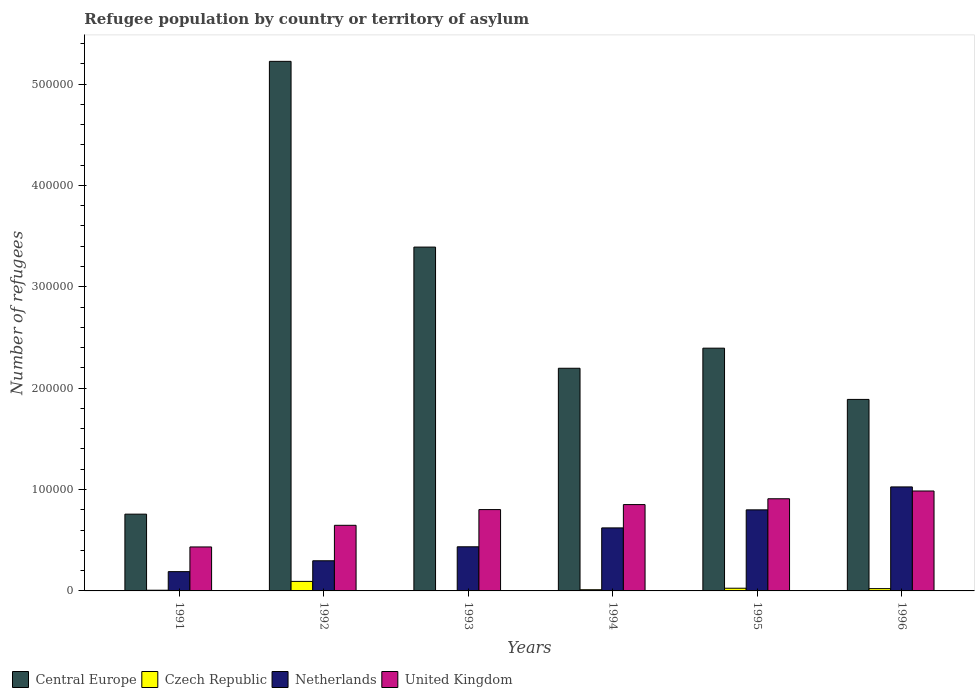Are the number of bars on each tick of the X-axis equal?
Give a very brief answer. Yes. How many bars are there on the 3rd tick from the right?
Your answer should be compact. 4. What is the label of the 5th group of bars from the left?
Provide a short and direct response. 1995. What is the number of refugees in Netherlands in 1992?
Your answer should be very brief. 2.97e+04. Across all years, what is the maximum number of refugees in Czech Republic?
Offer a terse response. 9399. Across all years, what is the minimum number of refugees in Czech Republic?
Give a very brief answer. 188. In which year was the number of refugees in Netherlands maximum?
Offer a very short reply. 1996. What is the total number of refugees in Czech Republic in the graph?
Offer a terse response. 1.64e+04. What is the difference between the number of refugees in United Kingdom in 1991 and that in 1993?
Ensure brevity in your answer.  -3.69e+04. What is the difference between the number of refugees in United Kingdom in 1991 and the number of refugees in Netherlands in 1995?
Your answer should be compact. -3.66e+04. What is the average number of refugees in Central Europe per year?
Your response must be concise. 2.64e+05. In the year 1993, what is the difference between the number of refugees in Central Europe and number of refugees in United Kingdom?
Provide a succinct answer. 2.59e+05. What is the ratio of the number of refugees in Czech Republic in 1991 to that in 1993?
Provide a short and direct response. 3.68. What is the difference between the highest and the second highest number of refugees in United Kingdom?
Offer a terse response. 7668. What is the difference between the highest and the lowest number of refugees in Czech Republic?
Offer a terse response. 9211. Is it the case that in every year, the sum of the number of refugees in Czech Republic and number of refugees in Netherlands is greater than the sum of number of refugees in United Kingdom and number of refugees in Central Europe?
Make the answer very short. No. What does the 3rd bar from the left in 1994 represents?
Ensure brevity in your answer.  Netherlands. What does the 1st bar from the right in 1995 represents?
Your answer should be compact. United Kingdom. How many bars are there?
Make the answer very short. 24. How many years are there in the graph?
Offer a terse response. 6. What is the difference between two consecutive major ticks on the Y-axis?
Your response must be concise. 1.00e+05. Does the graph contain any zero values?
Provide a short and direct response. No. What is the title of the graph?
Your response must be concise. Refugee population by country or territory of asylum. Does "Armenia" appear as one of the legend labels in the graph?
Give a very brief answer. No. What is the label or title of the Y-axis?
Offer a very short reply. Number of refugees. What is the Number of refugees of Central Europe in 1991?
Your response must be concise. 7.57e+04. What is the Number of refugees in Czech Republic in 1991?
Offer a very short reply. 691. What is the Number of refugees of Netherlands in 1991?
Your answer should be very brief. 1.90e+04. What is the Number of refugees in United Kingdom in 1991?
Offer a very short reply. 4.34e+04. What is the Number of refugees in Central Europe in 1992?
Give a very brief answer. 5.22e+05. What is the Number of refugees of Czech Republic in 1992?
Your answer should be compact. 9399. What is the Number of refugees of Netherlands in 1992?
Give a very brief answer. 2.97e+04. What is the Number of refugees of United Kingdom in 1992?
Your answer should be very brief. 6.47e+04. What is the Number of refugees in Central Europe in 1993?
Provide a short and direct response. 3.39e+05. What is the Number of refugees of Czech Republic in 1993?
Provide a succinct answer. 188. What is the Number of refugees of Netherlands in 1993?
Your answer should be very brief. 4.35e+04. What is the Number of refugees of United Kingdom in 1993?
Ensure brevity in your answer.  8.02e+04. What is the Number of refugees of Central Europe in 1994?
Provide a succinct answer. 2.20e+05. What is the Number of refugees of Czech Republic in 1994?
Your response must be concise. 1186. What is the Number of refugees in Netherlands in 1994?
Make the answer very short. 6.22e+04. What is the Number of refugees of United Kingdom in 1994?
Provide a short and direct response. 8.52e+04. What is the Number of refugees of Central Europe in 1995?
Your answer should be very brief. 2.39e+05. What is the Number of refugees of Czech Republic in 1995?
Offer a terse response. 2655. What is the Number of refugees in Netherlands in 1995?
Keep it short and to the point. 8.00e+04. What is the Number of refugees in United Kingdom in 1995?
Provide a short and direct response. 9.09e+04. What is the Number of refugees in Central Europe in 1996?
Offer a terse response. 1.89e+05. What is the Number of refugees in Czech Republic in 1996?
Give a very brief answer. 2266. What is the Number of refugees in Netherlands in 1996?
Provide a succinct answer. 1.03e+05. What is the Number of refugees of United Kingdom in 1996?
Provide a short and direct response. 9.86e+04. Across all years, what is the maximum Number of refugees in Central Europe?
Make the answer very short. 5.22e+05. Across all years, what is the maximum Number of refugees of Czech Republic?
Provide a short and direct response. 9399. Across all years, what is the maximum Number of refugees in Netherlands?
Your answer should be very brief. 1.03e+05. Across all years, what is the maximum Number of refugees in United Kingdom?
Offer a terse response. 9.86e+04. Across all years, what is the minimum Number of refugees of Central Europe?
Your response must be concise. 7.57e+04. Across all years, what is the minimum Number of refugees of Czech Republic?
Your answer should be very brief. 188. Across all years, what is the minimum Number of refugees in Netherlands?
Your answer should be very brief. 1.90e+04. Across all years, what is the minimum Number of refugees of United Kingdom?
Offer a very short reply. 4.34e+04. What is the total Number of refugees of Central Europe in the graph?
Offer a terse response. 1.59e+06. What is the total Number of refugees of Czech Republic in the graph?
Your answer should be compact. 1.64e+04. What is the total Number of refugees of Netherlands in the graph?
Make the answer very short. 3.37e+05. What is the total Number of refugees of United Kingdom in the graph?
Offer a very short reply. 4.63e+05. What is the difference between the Number of refugees in Central Europe in 1991 and that in 1992?
Offer a very short reply. -4.47e+05. What is the difference between the Number of refugees in Czech Republic in 1991 and that in 1992?
Your response must be concise. -8708. What is the difference between the Number of refugees of Netherlands in 1991 and that in 1992?
Your answer should be compact. -1.07e+04. What is the difference between the Number of refugees of United Kingdom in 1991 and that in 1992?
Ensure brevity in your answer.  -2.14e+04. What is the difference between the Number of refugees in Central Europe in 1991 and that in 1993?
Your answer should be very brief. -2.63e+05. What is the difference between the Number of refugees of Czech Republic in 1991 and that in 1993?
Provide a short and direct response. 503. What is the difference between the Number of refugees in Netherlands in 1991 and that in 1993?
Make the answer very short. -2.45e+04. What is the difference between the Number of refugees in United Kingdom in 1991 and that in 1993?
Ensure brevity in your answer.  -3.69e+04. What is the difference between the Number of refugees of Central Europe in 1991 and that in 1994?
Ensure brevity in your answer.  -1.44e+05. What is the difference between the Number of refugees in Czech Republic in 1991 and that in 1994?
Keep it short and to the point. -495. What is the difference between the Number of refugees in Netherlands in 1991 and that in 1994?
Ensure brevity in your answer.  -4.31e+04. What is the difference between the Number of refugees in United Kingdom in 1991 and that in 1994?
Offer a very short reply. -4.18e+04. What is the difference between the Number of refugees in Central Europe in 1991 and that in 1995?
Offer a very short reply. -1.64e+05. What is the difference between the Number of refugees of Czech Republic in 1991 and that in 1995?
Your answer should be compact. -1964. What is the difference between the Number of refugees of Netherlands in 1991 and that in 1995?
Keep it short and to the point. -6.09e+04. What is the difference between the Number of refugees in United Kingdom in 1991 and that in 1995?
Offer a terse response. -4.75e+04. What is the difference between the Number of refugees in Central Europe in 1991 and that in 1996?
Provide a short and direct response. -1.13e+05. What is the difference between the Number of refugees of Czech Republic in 1991 and that in 1996?
Provide a short and direct response. -1575. What is the difference between the Number of refugees of Netherlands in 1991 and that in 1996?
Make the answer very short. -8.36e+04. What is the difference between the Number of refugees of United Kingdom in 1991 and that in 1996?
Provide a short and direct response. -5.52e+04. What is the difference between the Number of refugees of Central Europe in 1992 and that in 1993?
Offer a terse response. 1.83e+05. What is the difference between the Number of refugees in Czech Republic in 1992 and that in 1993?
Ensure brevity in your answer.  9211. What is the difference between the Number of refugees in Netherlands in 1992 and that in 1993?
Offer a terse response. -1.38e+04. What is the difference between the Number of refugees in United Kingdom in 1992 and that in 1993?
Provide a succinct answer. -1.55e+04. What is the difference between the Number of refugees in Central Europe in 1992 and that in 1994?
Your answer should be compact. 3.03e+05. What is the difference between the Number of refugees in Czech Republic in 1992 and that in 1994?
Your response must be concise. 8213. What is the difference between the Number of refugees of Netherlands in 1992 and that in 1994?
Keep it short and to the point. -3.24e+04. What is the difference between the Number of refugees of United Kingdom in 1992 and that in 1994?
Offer a very short reply. -2.04e+04. What is the difference between the Number of refugees of Central Europe in 1992 and that in 1995?
Ensure brevity in your answer.  2.83e+05. What is the difference between the Number of refugees in Czech Republic in 1992 and that in 1995?
Keep it short and to the point. 6744. What is the difference between the Number of refugees in Netherlands in 1992 and that in 1995?
Your answer should be compact. -5.02e+04. What is the difference between the Number of refugees of United Kingdom in 1992 and that in 1995?
Provide a succinct answer. -2.62e+04. What is the difference between the Number of refugees in Central Europe in 1992 and that in 1996?
Your response must be concise. 3.33e+05. What is the difference between the Number of refugees of Czech Republic in 1992 and that in 1996?
Provide a succinct answer. 7133. What is the difference between the Number of refugees in Netherlands in 1992 and that in 1996?
Your answer should be very brief. -7.28e+04. What is the difference between the Number of refugees of United Kingdom in 1992 and that in 1996?
Keep it short and to the point. -3.39e+04. What is the difference between the Number of refugees of Central Europe in 1993 and that in 1994?
Your answer should be very brief. 1.20e+05. What is the difference between the Number of refugees of Czech Republic in 1993 and that in 1994?
Your answer should be very brief. -998. What is the difference between the Number of refugees in Netherlands in 1993 and that in 1994?
Your response must be concise. -1.86e+04. What is the difference between the Number of refugees of United Kingdom in 1993 and that in 1994?
Provide a short and direct response. -4930. What is the difference between the Number of refugees of Central Europe in 1993 and that in 1995?
Keep it short and to the point. 9.97e+04. What is the difference between the Number of refugees in Czech Republic in 1993 and that in 1995?
Make the answer very short. -2467. What is the difference between the Number of refugees of Netherlands in 1993 and that in 1995?
Ensure brevity in your answer.  -3.64e+04. What is the difference between the Number of refugees in United Kingdom in 1993 and that in 1995?
Provide a succinct answer. -1.07e+04. What is the difference between the Number of refugees of Central Europe in 1993 and that in 1996?
Your answer should be compact. 1.50e+05. What is the difference between the Number of refugees in Czech Republic in 1993 and that in 1996?
Provide a short and direct response. -2078. What is the difference between the Number of refugees of Netherlands in 1993 and that in 1996?
Make the answer very short. -5.90e+04. What is the difference between the Number of refugees of United Kingdom in 1993 and that in 1996?
Ensure brevity in your answer.  -1.83e+04. What is the difference between the Number of refugees of Central Europe in 1994 and that in 1995?
Give a very brief answer. -1.98e+04. What is the difference between the Number of refugees of Czech Republic in 1994 and that in 1995?
Provide a short and direct response. -1469. What is the difference between the Number of refugees in Netherlands in 1994 and that in 1995?
Provide a succinct answer. -1.78e+04. What is the difference between the Number of refugees of United Kingdom in 1994 and that in 1995?
Provide a succinct answer. -5749. What is the difference between the Number of refugees in Central Europe in 1994 and that in 1996?
Give a very brief answer. 3.07e+04. What is the difference between the Number of refugees of Czech Republic in 1994 and that in 1996?
Your answer should be compact. -1080. What is the difference between the Number of refugees in Netherlands in 1994 and that in 1996?
Your answer should be very brief. -4.04e+04. What is the difference between the Number of refugees of United Kingdom in 1994 and that in 1996?
Give a very brief answer. -1.34e+04. What is the difference between the Number of refugees of Central Europe in 1995 and that in 1996?
Keep it short and to the point. 5.06e+04. What is the difference between the Number of refugees of Czech Republic in 1995 and that in 1996?
Keep it short and to the point. 389. What is the difference between the Number of refugees of Netherlands in 1995 and that in 1996?
Offer a terse response. -2.26e+04. What is the difference between the Number of refugees of United Kingdom in 1995 and that in 1996?
Your answer should be compact. -7668. What is the difference between the Number of refugees in Central Europe in 1991 and the Number of refugees in Czech Republic in 1992?
Make the answer very short. 6.63e+04. What is the difference between the Number of refugees of Central Europe in 1991 and the Number of refugees of Netherlands in 1992?
Your answer should be very brief. 4.60e+04. What is the difference between the Number of refugees of Central Europe in 1991 and the Number of refugees of United Kingdom in 1992?
Make the answer very short. 1.10e+04. What is the difference between the Number of refugees in Czech Republic in 1991 and the Number of refugees in Netherlands in 1992?
Your answer should be compact. -2.90e+04. What is the difference between the Number of refugees in Czech Republic in 1991 and the Number of refugees in United Kingdom in 1992?
Make the answer very short. -6.40e+04. What is the difference between the Number of refugees in Netherlands in 1991 and the Number of refugees in United Kingdom in 1992?
Offer a very short reply. -4.57e+04. What is the difference between the Number of refugees of Central Europe in 1991 and the Number of refugees of Czech Republic in 1993?
Offer a terse response. 7.55e+04. What is the difference between the Number of refugees in Central Europe in 1991 and the Number of refugees in Netherlands in 1993?
Offer a very short reply. 3.22e+04. What is the difference between the Number of refugees in Central Europe in 1991 and the Number of refugees in United Kingdom in 1993?
Your response must be concise. -4500. What is the difference between the Number of refugees of Czech Republic in 1991 and the Number of refugees of Netherlands in 1993?
Your response must be concise. -4.28e+04. What is the difference between the Number of refugees of Czech Republic in 1991 and the Number of refugees of United Kingdom in 1993?
Give a very brief answer. -7.95e+04. What is the difference between the Number of refugees of Netherlands in 1991 and the Number of refugees of United Kingdom in 1993?
Offer a very short reply. -6.12e+04. What is the difference between the Number of refugees of Central Europe in 1991 and the Number of refugees of Czech Republic in 1994?
Your answer should be very brief. 7.45e+04. What is the difference between the Number of refugees of Central Europe in 1991 and the Number of refugees of Netherlands in 1994?
Make the answer very short. 1.36e+04. What is the difference between the Number of refugees of Central Europe in 1991 and the Number of refugees of United Kingdom in 1994?
Offer a terse response. -9430. What is the difference between the Number of refugees in Czech Republic in 1991 and the Number of refugees in Netherlands in 1994?
Offer a very short reply. -6.15e+04. What is the difference between the Number of refugees of Czech Republic in 1991 and the Number of refugees of United Kingdom in 1994?
Offer a terse response. -8.45e+04. What is the difference between the Number of refugees of Netherlands in 1991 and the Number of refugees of United Kingdom in 1994?
Your response must be concise. -6.61e+04. What is the difference between the Number of refugees of Central Europe in 1991 and the Number of refugees of Czech Republic in 1995?
Offer a terse response. 7.31e+04. What is the difference between the Number of refugees of Central Europe in 1991 and the Number of refugees of Netherlands in 1995?
Offer a very short reply. -4230. What is the difference between the Number of refugees in Central Europe in 1991 and the Number of refugees in United Kingdom in 1995?
Your answer should be very brief. -1.52e+04. What is the difference between the Number of refugees in Czech Republic in 1991 and the Number of refugees in Netherlands in 1995?
Offer a terse response. -7.93e+04. What is the difference between the Number of refugees in Czech Republic in 1991 and the Number of refugees in United Kingdom in 1995?
Make the answer very short. -9.02e+04. What is the difference between the Number of refugees in Netherlands in 1991 and the Number of refugees in United Kingdom in 1995?
Keep it short and to the point. -7.19e+04. What is the difference between the Number of refugees of Central Europe in 1991 and the Number of refugees of Czech Republic in 1996?
Keep it short and to the point. 7.35e+04. What is the difference between the Number of refugees of Central Europe in 1991 and the Number of refugees of Netherlands in 1996?
Offer a very short reply. -2.69e+04. What is the difference between the Number of refugees of Central Europe in 1991 and the Number of refugees of United Kingdom in 1996?
Provide a succinct answer. -2.28e+04. What is the difference between the Number of refugees of Czech Republic in 1991 and the Number of refugees of Netherlands in 1996?
Your response must be concise. -1.02e+05. What is the difference between the Number of refugees of Czech Republic in 1991 and the Number of refugees of United Kingdom in 1996?
Give a very brief answer. -9.79e+04. What is the difference between the Number of refugees in Netherlands in 1991 and the Number of refugees in United Kingdom in 1996?
Your response must be concise. -7.96e+04. What is the difference between the Number of refugees in Central Europe in 1992 and the Number of refugees in Czech Republic in 1993?
Your answer should be very brief. 5.22e+05. What is the difference between the Number of refugees in Central Europe in 1992 and the Number of refugees in Netherlands in 1993?
Your answer should be compact. 4.79e+05. What is the difference between the Number of refugees in Central Europe in 1992 and the Number of refugees in United Kingdom in 1993?
Offer a terse response. 4.42e+05. What is the difference between the Number of refugees of Czech Republic in 1992 and the Number of refugees of Netherlands in 1993?
Your response must be concise. -3.41e+04. What is the difference between the Number of refugees in Czech Republic in 1992 and the Number of refugees in United Kingdom in 1993?
Keep it short and to the point. -7.08e+04. What is the difference between the Number of refugees of Netherlands in 1992 and the Number of refugees of United Kingdom in 1993?
Your answer should be compact. -5.05e+04. What is the difference between the Number of refugees of Central Europe in 1992 and the Number of refugees of Czech Republic in 1994?
Keep it short and to the point. 5.21e+05. What is the difference between the Number of refugees of Central Europe in 1992 and the Number of refugees of Netherlands in 1994?
Keep it short and to the point. 4.60e+05. What is the difference between the Number of refugees in Central Europe in 1992 and the Number of refugees in United Kingdom in 1994?
Offer a terse response. 4.37e+05. What is the difference between the Number of refugees in Czech Republic in 1992 and the Number of refugees in Netherlands in 1994?
Keep it short and to the point. -5.28e+04. What is the difference between the Number of refugees of Czech Republic in 1992 and the Number of refugees of United Kingdom in 1994?
Your answer should be compact. -7.58e+04. What is the difference between the Number of refugees in Netherlands in 1992 and the Number of refugees in United Kingdom in 1994?
Your response must be concise. -5.54e+04. What is the difference between the Number of refugees in Central Europe in 1992 and the Number of refugees in Czech Republic in 1995?
Offer a terse response. 5.20e+05. What is the difference between the Number of refugees in Central Europe in 1992 and the Number of refugees in Netherlands in 1995?
Provide a succinct answer. 4.42e+05. What is the difference between the Number of refugees in Central Europe in 1992 and the Number of refugees in United Kingdom in 1995?
Offer a very short reply. 4.31e+05. What is the difference between the Number of refugees in Czech Republic in 1992 and the Number of refugees in Netherlands in 1995?
Your answer should be very brief. -7.06e+04. What is the difference between the Number of refugees of Czech Republic in 1992 and the Number of refugees of United Kingdom in 1995?
Keep it short and to the point. -8.15e+04. What is the difference between the Number of refugees in Netherlands in 1992 and the Number of refugees in United Kingdom in 1995?
Provide a succinct answer. -6.12e+04. What is the difference between the Number of refugees of Central Europe in 1992 and the Number of refugees of Czech Republic in 1996?
Your answer should be compact. 5.20e+05. What is the difference between the Number of refugees in Central Europe in 1992 and the Number of refugees in Netherlands in 1996?
Ensure brevity in your answer.  4.20e+05. What is the difference between the Number of refugees in Central Europe in 1992 and the Number of refugees in United Kingdom in 1996?
Ensure brevity in your answer.  4.24e+05. What is the difference between the Number of refugees of Czech Republic in 1992 and the Number of refugees of Netherlands in 1996?
Offer a terse response. -9.32e+04. What is the difference between the Number of refugees of Czech Republic in 1992 and the Number of refugees of United Kingdom in 1996?
Your answer should be very brief. -8.92e+04. What is the difference between the Number of refugees in Netherlands in 1992 and the Number of refugees in United Kingdom in 1996?
Offer a terse response. -6.88e+04. What is the difference between the Number of refugees of Central Europe in 1993 and the Number of refugees of Czech Republic in 1994?
Your response must be concise. 3.38e+05. What is the difference between the Number of refugees of Central Europe in 1993 and the Number of refugees of Netherlands in 1994?
Your response must be concise. 2.77e+05. What is the difference between the Number of refugees of Central Europe in 1993 and the Number of refugees of United Kingdom in 1994?
Your answer should be very brief. 2.54e+05. What is the difference between the Number of refugees of Czech Republic in 1993 and the Number of refugees of Netherlands in 1994?
Your response must be concise. -6.20e+04. What is the difference between the Number of refugees of Czech Republic in 1993 and the Number of refugees of United Kingdom in 1994?
Your response must be concise. -8.50e+04. What is the difference between the Number of refugees in Netherlands in 1993 and the Number of refugees in United Kingdom in 1994?
Your response must be concise. -4.16e+04. What is the difference between the Number of refugees of Central Europe in 1993 and the Number of refugees of Czech Republic in 1995?
Keep it short and to the point. 3.37e+05. What is the difference between the Number of refugees in Central Europe in 1993 and the Number of refugees in Netherlands in 1995?
Your response must be concise. 2.59e+05. What is the difference between the Number of refugees of Central Europe in 1993 and the Number of refugees of United Kingdom in 1995?
Provide a succinct answer. 2.48e+05. What is the difference between the Number of refugees of Czech Republic in 1993 and the Number of refugees of Netherlands in 1995?
Provide a succinct answer. -7.98e+04. What is the difference between the Number of refugees of Czech Republic in 1993 and the Number of refugees of United Kingdom in 1995?
Provide a succinct answer. -9.07e+04. What is the difference between the Number of refugees in Netherlands in 1993 and the Number of refugees in United Kingdom in 1995?
Make the answer very short. -4.74e+04. What is the difference between the Number of refugees in Central Europe in 1993 and the Number of refugees in Czech Republic in 1996?
Your answer should be compact. 3.37e+05. What is the difference between the Number of refugees in Central Europe in 1993 and the Number of refugees in Netherlands in 1996?
Provide a succinct answer. 2.37e+05. What is the difference between the Number of refugees of Central Europe in 1993 and the Number of refugees of United Kingdom in 1996?
Offer a terse response. 2.41e+05. What is the difference between the Number of refugees in Czech Republic in 1993 and the Number of refugees in Netherlands in 1996?
Offer a very short reply. -1.02e+05. What is the difference between the Number of refugees of Czech Republic in 1993 and the Number of refugees of United Kingdom in 1996?
Offer a terse response. -9.84e+04. What is the difference between the Number of refugees in Netherlands in 1993 and the Number of refugees in United Kingdom in 1996?
Your response must be concise. -5.50e+04. What is the difference between the Number of refugees of Central Europe in 1994 and the Number of refugees of Czech Republic in 1995?
Offer a very short reply. 2.17e+05. What is the difference between the Number of refugees of Central Europe in 1994 and the Number of refugees of Netherlands in 1995?
Your answer should be compact. 1.40e+05. What is the difference between the Number of refugees of Central Europe in 1994 and the Number of refugees of United Kingdom in 1995?
Offer a very short reply. 1.29e+05. What is the difference between the Number of refugees in Czech Republic in 1994 and the Number of refugees in Netherlands in 1995?
Ensure brevity in your answer.  -7.88e+04. What is the difference between the Number of refugees of Czech Republic in 1994 and the Number of refugees of United Kingdom in 1995?
Make the answer very short. -8.97e+04. What is the difference between the Number of refugees in Netherlands in 1994 and the Number of refugees in United Kingdom in 1995?
Give a very brief answer. -2.87e+04. What is the difference between the Number of refugees of Central Europe in 1994 and the Number of refugees of Czech Republic in 1996?
Ensure brevity in your answer.  2.17e+05. What is the difference between the Number of refugees in Central Europe in 1994 and the Number of refugees in Netherlands in 1996?
Ensure brevity in your answer.  1.17e+05. What is the difference between the Number of refugees of Central Europe in 1994 and the Number of refugees of United Kingdom in 1996?
Keep it short and to the point. 1.21e+05. What is the difference between the Number of refugees in Czech Republic in 1994 and the Number of refugees in Netherlands in 1996?
Ensure brevity in your answer.  -1.01e+05. What is the difference between the Number of refugees in Czech Republic in 1994 and the Number of refugees in United Kingdom in 1996?
Your response must be concise. -9.74e+04. What is the difference between the Number of refugees in Netherlands in 1994 and the Number of refugees in United Kingdom in 1996?
Give a very brief answer. -3.64e+04. What is the difference between the Number of refugees of Central Europe in 1995 and the Number of refugees of Czech Republic in 1996?
Offer a terse response. 2.37e+05. What is the difference between the Number of refugees of Central Europe in 1995 and the Number of refugees of Netherlands in 1996?
Your answer should be compact. 1.37e+05. What is the difference between the Number of refugees of Central Europe in 1995 and the Number of refugees of United Kingdom in 1996?
Provide a succinct answer. 1.41e+05. What is the difference between the Number of refugees of Czech Republic in 1995 and the Number of refugees of Netherlands in 1996?
Offer a terse response. -9.99e+04. What is the difference between the Number of refugees of Czech Republic in 1995 and the Number of refugees of United Kingdom in 1996?
Give a very brief answer. -9.59e+04. What is the difference between the Number of refugees in Netherlands in 1995 and the Number of refugees in United Kingdom in 1996?
Ensure brevity in your answer.  -1.86e+04. What is the average Number of refugees in Central Europe per year?
Provide a succinct answer. 2.64e+05. What is the average Number of refugees in Czech Republic per year?
Give a very brief answer. 2730.83. What is the average Number of refugees in Netherlands per year?
Offer a terse response. 5.62e+04. What is the average Number of refugees of United Kingdom per year?
Keep it short and to the point. 7.72e+04. In the year 1991, what is the difference between the Number of refugees of Central Europe and Number of refugees of Czech Republic?
Make the answer very short. 7.50e+04. In the year 1991, what is the difference between the Number of refugees of Central Europe and Number of refugees of Netherlands?
Offer a very short reply. 5.67e+04. In the year 1991, what is the difference between the Number of refugees of Central Europe and Number of refugees of United Kingdom?
Offer a very short reply. 3.24e+04. In the year 1991, what is the difference between the Number of refugees of Czech Republic and Number of refugees of Netherlands?
Ensure brevity in your answer.  -1.83e+04. In the year 1991, what is the difference between the Number of refugees of Czech Republic and Number of refugees of United Kingdom?
Your answer should be compact. -4.27e+04. In the year 1991, what is the difference between the Number of refugees of Netherlands and Number of refugees of United Kingdom?
Ensure brevity in your answer.  -2.44e+04. In the year 1992, what is the difference between the Number of refugees of Central Europe and Number of refugees of Czech Republic?
Give a very brief answer. 5.13e+05. In the year 1992, what is the difference between the Number of refugees in Central Europe and Number of refugees in Netherlands?
Make the answer very short. 4.93e+05. In the year 1992, what is the difference between the Number of refugees in Central Europe and Number of refugees in United Kingdom?
Keep it short and to the point. 4.58e+05. In the year 1992, what is the difference between the Number of refugees of Czech Republic and Number of refugees of Netherlands?
Ensure brevity in your answer.  -2.03e+04. In the year 1992, what is the difference between the Number of refugees of Czech Republic and Number of refugees of United Kingdom?
Ensure brevity in your answer.  -5.53e+04. In the year 1992, what is the difference between the Number of refugees in Netherlands and Number of refugees in United Kingdom?
Offer a terse response. -3.50e+04. In the year 1993, what is the difference between the Number of refugees of Central Europe and Number of refugees of Czech Republic?
Give a very brief answer. 3.39e+05. In the year 1993, what is the difference between the Number of refugees in Central Europe and Number of refugees in Netherlands?
Make the answer very short. 2.96e+05. In the year 1993, what is the difference between the Number of refugees of Central Europe and Number of refugees of United Kingdom?
Your answer should be compact. 2.59e+05. In the year 1993, what is the difference between the Number of refugees of Czech Republic and Number of refugees of Netherlands?
Your answer should be compact. -4.34e+04. In the year 1993, what is the difference between the Number of refugees of Czech Republic and Number of refugees of United Kingdom?
Your answer should be very brief. -8.00e+04. In the year 1993, what is the difference between the Number of refugees in Netherlands and Number of refugees in United Kingdom?
Provide a succinct answer. -3.67e+04. In the year 1994, what is the difference between the Number of refugees of Central Europe and Number of refugees of Czech Republic?
Provide a short and direct response. 2.18e+05. In the year 1994, what is the difference between the Number of refugees of Central Europe and Number of refugees of Netherlands?
Offer a terse response. 1.57e+05. In the year 1994, what is the difference between the Number of refugees of Central Europe and Number of refugees of United Kingdom?
Provide a succinct answer. 1.34e+05. In the year 1994, what is the difference between the Number of refugees of Czech Republic and Number of refugees of Netherlands?
Your response must be concise. -6.10e+04. In the year 1994, what is the difference between the Number of refugees of Czech Republic and Number of refugees of United Kingdom?
Ensure brevity in your answer.  -8.40e+04. In the year 1994, what is the difference between the Number of refugees in Netherlands and Number of refugees in United Kingdom?
Ensure brevity in your answer.  -2.30e+04. In the year 1995, what is the difference between the Number of refugees of Central Europe and Number of refugees of Czech Republic?
Ensure brevity in your answer.  2.37e+05. In the year 1995, what is the difference between the Number of refugees of Central Europe and Number of refugees of Netherlands?
Provide a succinct answer. 1.60e+05. In the year 1995, what is the difference between the Number of refugees in Central Europe and Number of refugees in United Kingdom?
Your answer should be very brief. 1.49e+05. In the year 1995, what is the difference between the Number of refugees in Czech Republic and Number of refugees in Netherlands?
Provide a short and direct response. -7.73e+04. In the year 1995, what is the difference between the Number of refugees of Czech Republic and Number of refugees of United Kingdom?
Your response must be concise. -8.83e+04. In the year 1995, what is the difference between the Number of refugees in Netherlands and Number of refugees in United Kingdom?
Offer a very short reply. -1.09e+04. In the year 1996, what is the difference between the Number of refugees in Central Europe and Number of refugees in Czech Republic?
Provide a succinct answer. 1.87e+05. In the year 1996, what is the difference between the Number of refugees of Central Europe and Number of refugees of Netherlands?
Provide a short and direct response. 8.63e+04. In the year 1996, what is the difference between the Number of refugees of Central Europe and Number of refugees of United Kingdom?
Offer a very short reply. 9.03e+04. In the year 1996, what is the difference between the Number of refugees of Czech Republic and Number of refugees of Netherlands?
Your answer should be compact. -1.00e+05. In the year 1996, what is the difference between the Number of refugees in Czech Republic and Number of refugees in United Kingdom?
Ensure brevity in your answer.  -9.63e+04. In the year 1996, what is the difference between the Number of refugees of Netherlands and Number of refugees of United Kingdom?
Provide a succinct answer. 4011. What is the ratio of the Number of refugees of Central Europe in 1991 to that in 1992?
Your answer should be very brief. 0.14. What is the ratio of the Number of refugees in Czech Republic in 1991 to that in 1992?
Keep it short and to the point. 0.07. What is the ratio of the Number of refugees of Netherlands in 1991 to that in 1992?
Ensure brevity in your answer.  0.64. What is the ratio of the Number of refugees in United Kingdom in 1991 to that in 1992?
Provide a short and direct response. 0.67. What is the ratio of the Number of refugees in Central Europe in 1991 to that in 1993?
Offer a terse response. 0.22. What is the ratio of the Number of refugees of Czech Republic in 1991 to that in 1993?
Give a very brief answer. 3.68. What is the ratio of the Number of refugees of Netherlands in 1991 to that in 1993?
Your response must be concise. 0.44. What is the ratio of the Number of refugees of United Kingdom in 1991 to that in 1993?
Provide a succinct answer. 0.54. What is the ratio of the Number of refugees of Central Europe in 1991 to that in 1994?
Give a very brief answer. 0.34. What is the ratio of the Number of refugees in Czech Republic in 1991 to that in 1994?
Provide a succinct answer. 0.58. What is the ratio of the Number of refugees of Netherlands in 1991 to that in 1994?
Your answer should be very brief. 0.31. What is the ratio of the Number of refugees in United Kingdom in 1991 to that in 1994?
Provide a succinct answer. 0.51. What is the ratio of the Number of refugees of Central Europe in 1991 to that in 1995?
Your response must be concise. 0.32. What is the ratio of the Number of refugees in Czech Republic in 1991 to that in 1995?
Keep it short and to the point. 0.26. What is the ratio of the Number of refugees of Netherlands in 1991 to that in 1995?
Make the answer very short. 0.24. What is the ratio of the Number of refugees in United Kingdom in 1991 to that in 1995?
Provide a short and direct response. 0.48. What is the ratio of the Number of refugees of Central Europe in 1991 to that in 1996?
Offer a very short reply. 0.4. What is the ratio of the Number of refugees in Czech Republic in 1991 to that in 1996?
Provide a short and direct response. 0.3. What is the ratio of the Number of refugees of Netherlands in 1991 to that in 1996?
Offer a very short reply. 0.19. What is the ratio of the Number of refugees of United Kingdom in 1991 to that in 1996?
Provide a short and direct response. 0.44. What is the ratio of the Number of refugees in Central Europe in 1992 to that in 1993?
Offer a very short reply. 1.54. What is the ratio of the Number of refugees in Czech Republic in 1992 to that in 1993?
Provide a short and direct response. 49.99. What is the ratio of the Number of refugees in Netherlands in 1992 to that in 1993?
Give a very brief answer. 0.68. What is the ratio of the Number of refugees of United Kingdom in 1992 to that in 1993?
Keep it short and to the point. 0.81. What is the ratio of the Number of refugees of Central Europe in 1992 to that in 1994?
Make the answer very short. 2.38. What is the ratio of the Number of refugees in Czech Republic in 1992 to that in 1994?
Offer a very short reply. 7.92. What is the ratio of the Number of refugees in Netherlands in 1992 to that in 1994?
Your answer should be compact. 0.48. What is the ratio of the Number of refugees of United Kingdom in 1992 to that in 1994?
Your response must be concise. 0.76. What is the ratio of the Number of refugees of Central Europe in 1992 to that in 1995?
Your answer should be very brief. 2.18. What is the ratio of the Number of refugees in Czech Republic in 1992 to that in 1995?
Your answer should be compact. 3.54. What is the ratio of the Number of refugees of Netherlands in 1992 to that in 1995?
Keep it short and to the point. 0.37. What is the ratio of the Number of refugees of United Kingdom in 1992 to that in 1995?
Keep it short and to the point. 0.71. What is the ratio of the Number of refugees in Central Europe in 1992 to that in 1996?
Your answer should be compact. 2.77. What is the ratio of the Number of refugees in Czech Republic in 1992 to that in 1996?
Provide a short and direct response. 4.15. What is the ratio of the Number of refugees of Netherlands in 1992 to that in 1996?
Provide a short and direct response. 0.29. What is the ratio of the Number of refugees of United Kingdom in 1992 to that in 1996?
Keep it short and to the point. 0.66. What is the ratio of the Number of refugees in Central Europe in 1993 to that in 1994?
Provide a short and direct response. 1.54. What is the ratio of the Number of refugees of Czech Republic in 1993 to that in 1994?
Your answer should be compact. 0.16. What is the ratio of the Number of refugees of Netherlands in 1993 to that in 1994?
Your response must be concise. 0.7. What is the ratio of the Number of refugees in United Kingdom in 1993 to that in 1994?
Provide a short and direct response. 0.94. What is the ratio of the Number of refugees in Central Europe in 1993 to that in 1995?
Provide a short and direct response. 1.42. What is the ratio of the Number of refugees in Czech Republic in 1993 to that in 1995?
Your answer should be compact. 0.07. What is the ratio of the Number of refugees in Netherlands in 1993 to that in 1995?
Offer a terse response. 0.54. What is the ratio of the Number of refugees in United Kingdom in 1993 to that in 1995?
Offer a very short reply. 0.88. What is the ratio of the Number of refugees of Central Europe in 1993 to that in 1996?
Keep it short and to the point. 1.8. What is the ratio of the Number of refugees of Czech Republic in 1993 to that in 1996?
Offer a terse response. 0.08. What is the ratio of the Number of refugees of Netherlands in 1993 to that in 1996?
Make the answer very short. 0.42. What is the ratio of the Number of refugees in United Kingdom in 1993 to that in 1996?
Keep it short and to the point. 0.81. What is the ratio of the Number of refugees of Central Europe in 1994 to that in 1995?
Ensure brevity in your answer.  0.92. What is the ratio of the Number of refugees in Czech Republic in 1994 to that in 1995?
Provide a succinct answer. 0.45. What is the ratio of the Number of refugees in Netherlands in 1994 to that in 1995?
Your answer should be very brief. 0.78. What is the ratio of the Number of refugees of United Kingdom in 1994 to that in 1995?
Keep it short and to the point. 0.94. What is the ratio of the Number of refugees of Central Europe in 1994 to that in 1996?
Your answer should be very brief. 1.16. What is the ratio of the Number of refugees of Czech Republic in 1994 to that in 1996?
Offer a very short reply. 0.52. What is the ratio of the Number of refugees of Netherlands in 1994 to that in 1996?
Your response must be concise. 0.61. What is the ratio of the Number of refugees in United Kingdom in 1994 to that in 1996?
Keep it short and to the point. 0.86. What is the ratio of the Number of refugees in Central Europe in 1995 to that in 1996?
Offer a terse response. 1.27. What is the ratio of the Number of refugees in Czech Republic in 1995 to that in 1996?
Keep it short and to the point. 1.17. What is the ratio of the Number of refugees of Netherlands in 1995 to that in 1996?
Offer a very short reply. 0.78. What is the ratio of the Number of refugees of United Kingdom in 1995 to that in 1996?
Keep it short and to the point. 0.92. What is the difference between the highest and the second highest Number of refugees in Central Europe?
Your response must be concise. 1.83e+05. What is the difference between the highest and the second highest Number of refugees of Czech Republic?
Offer a very short reply. 6744. What is the difference between the highest and the second highest Number of refugees in Netherlands?
Your answer should be compact. 2.26e+04. What is the difference between the highest and the second highest Number of refugees in United Kingdom?
Keep it short and to the point. 7668. What is the difference between the highest and the lowest Number of refugees in Central Europe?
Offer a very short reply. 4.47e+05. What is the difference between the highest and the lowest Number of refugees in Czech Republic?
Your answer should be compact. 9211. What is the difference between the highest and the lowest Number of refugees of Netherlands?
Offer a terse response. 8.36e+04. What is the difference between the highest and the lowest Number of refugees in United Kingdom?
Provide a succinct answer. 5.52e+04. 